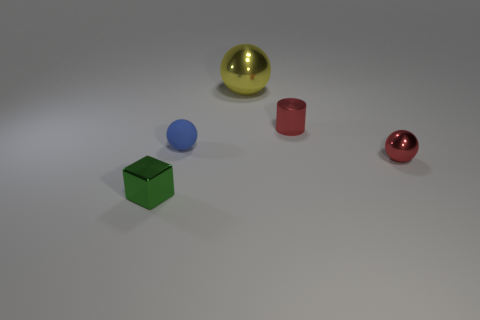Are there any other things that are the same material as the small blue ball?
Offer a very short reply. No. What number of red objects are the same size as the cube?
Keep it short and to the point. 2. How many tiny objects are behind the tiny sphere that is in front of the small blue rubber sphere?
Ensure brevity in your answer.  2. How big is the metallic object that is both behind the small metallic sphere and on the left side of the cylinder?
Ensure brevity in your answer.  Large. Are there more blue things than gray shiny cylinders?
Your answer should be very brief. Yes. Is there a metallic thing of the same color as the small metal cylinder?
Keep it short and to the point. Yes. Do the metal sphere that is left of the red metal ball and the rubber object have the same size?
Provide a succinct answer. No. Is the number of red objects less than the number of tiny yellow matte cylinders?
Make the answer very short. No. Is there a small red ball made of the same material as the tiny green cube?
Offer a very short reply. Yes. What shape is the small metallic thing on the left side of the large yellow shiny ball?
Make the answer very short. Cube. 